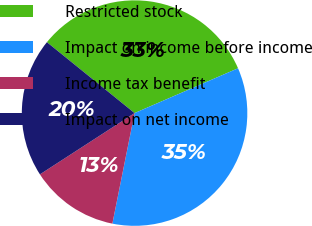<chart> <loc_0><loc_0><loc_500><loc_500><pie_chart><fcel>Restricted stock<fcel>Impact on income before income<fcel>Income tax benefit<fcel>Impact on net income<nl><fcel>32.67%<fcel>34.66%<fcel>12.7%<fcel>19.97%<nl></chart> 